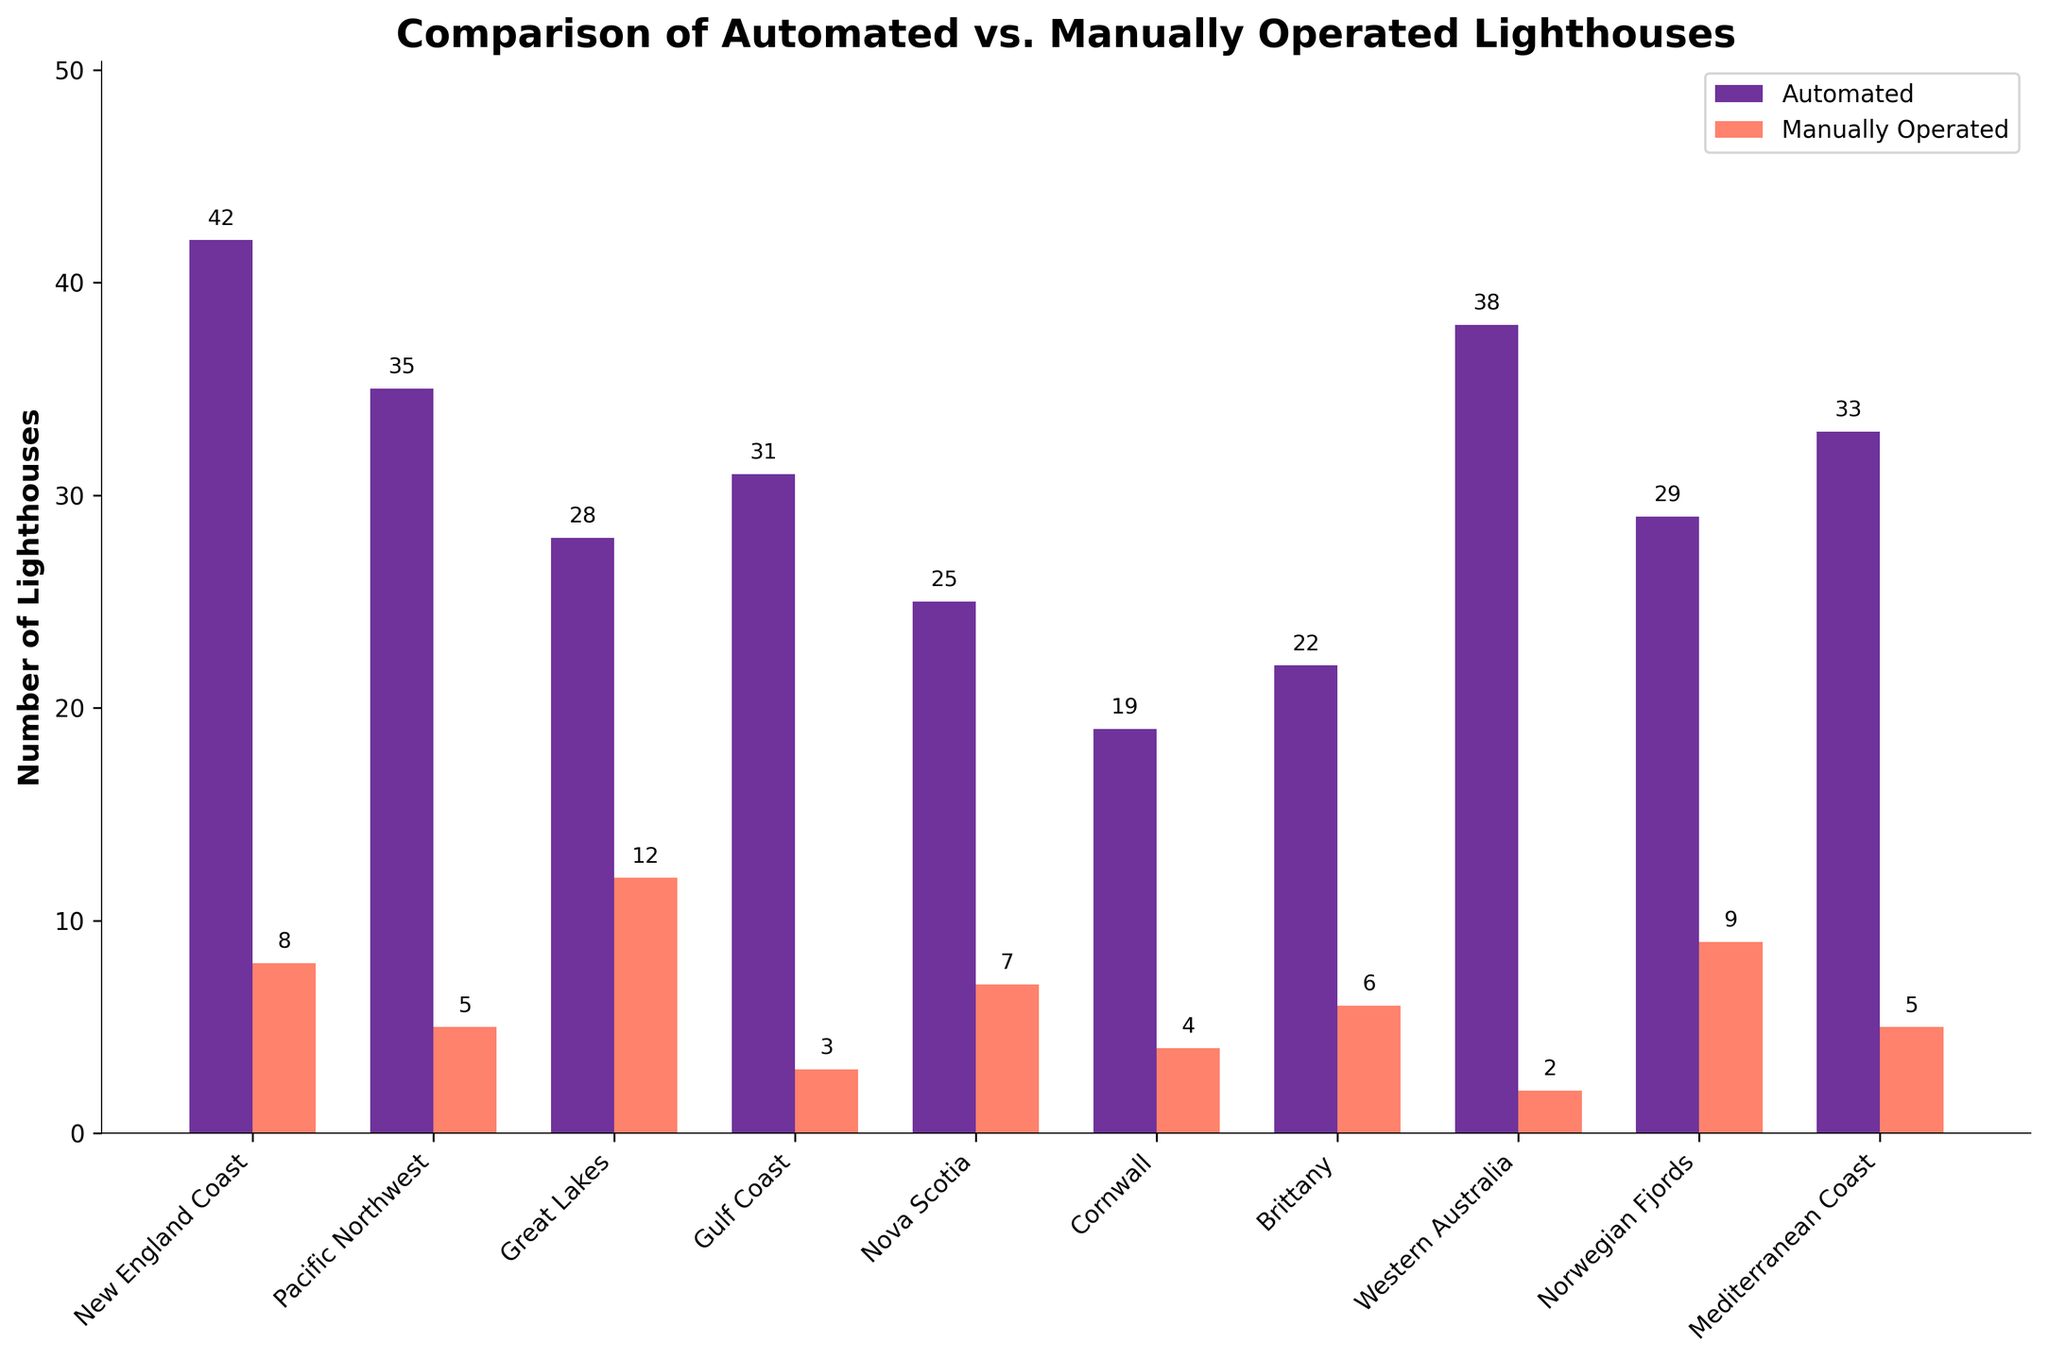What is the total number of automated lighthouses in all the regions combined? Sum the number of automated lighthouses across all regions: 42 + 35 + 28 + 31 + 25 + 19 + 22 + 38 + 29 + 33 = 302.
Answer: 302 Which region has the highest number of manually operated lighthouses? Compare the manually operated lighthouse numbers for each region: 8 (New England Coast), 5 (Pacific Northwest), 12 (Great Lakes), 3 (Gulf Coast), 7 (Nova Scotia), 4 (Cornwall), 6 (Brittany), 2 (Western Australia), 9 (Norwegian Fjords), 5 (Mediterranean Coast). The Great Lakes has the highest number at 12.
Answer: Great Lakes Is the number of automated lighthouses greater than manually operated ones in every region? Check for each region if the number of automated lighthouses is greater than manually operated ones: Yes for all regions.
Answer: Yes How many more automated lighthouses are there in New England Coast compared to manually operated ones there? Subtract the number of manually operated lighthouses in New England Coast from the automated ones: 42 - 8 = 34.
Answer: 34 Which two regions have the same number of manually operated lighthouses? Identify regions with equal numbers of manually operated lighthouses: Both Pacific Northwest and Mediterranean Coast have 5 manually operated lighthouses.
Answer: Pacific Northwest and Mediterranean Coast What is the difference in the number of automated lighthouses between Western Australia and Norwegian Fjords? Subtract the number of automated lighthouses in Norwegian Fjords from Western Australia: 38 - 29 = 9.
Answer: 9 Which region has the lowest number of total lighthouses (both automated and manually operated combined)? Calculate the total number of lighthouses for each region and find the lowest: New England Coast (50), Pacific Northwest (40), Great Lakes (40), Gulf Coast (34), Nova Scotia (32), Cornwall (23), Brittany (28), Western Australia (40), Norwegian Fjords (38), Mediterranean Coast (38). Cornwall has the lowest number at 23.
Answer: Cornwall How many more automated lighthouses are there than manually operated lighthouses in the entire Mediterranean Coast region? Subtract the number of manually operated lighthouses from automated lighthouses in Mediterranean Coast: 33 - 5 = 28.
Answer: 28 What is the average number of manual lighthouses per region? Sum the total number of manually operated lighthouses and divide by the number of regions: (8 + 5 + 12 + 3 + 7 + 4 + 6 + 2 + 9 + 5) / 10 = 61 / 10 = 6.1.
Answer: 6.1 